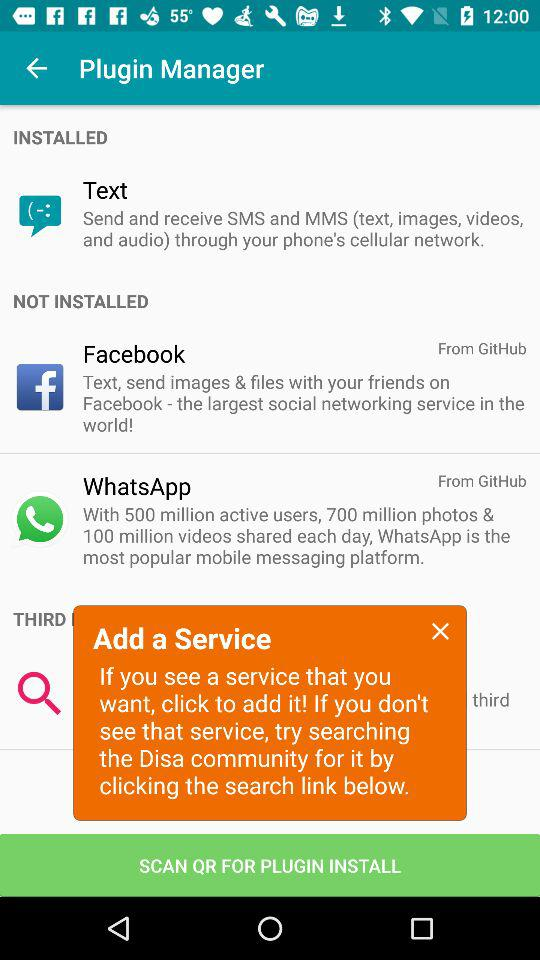Which plugin is installed? The installed plugin is "Text". 